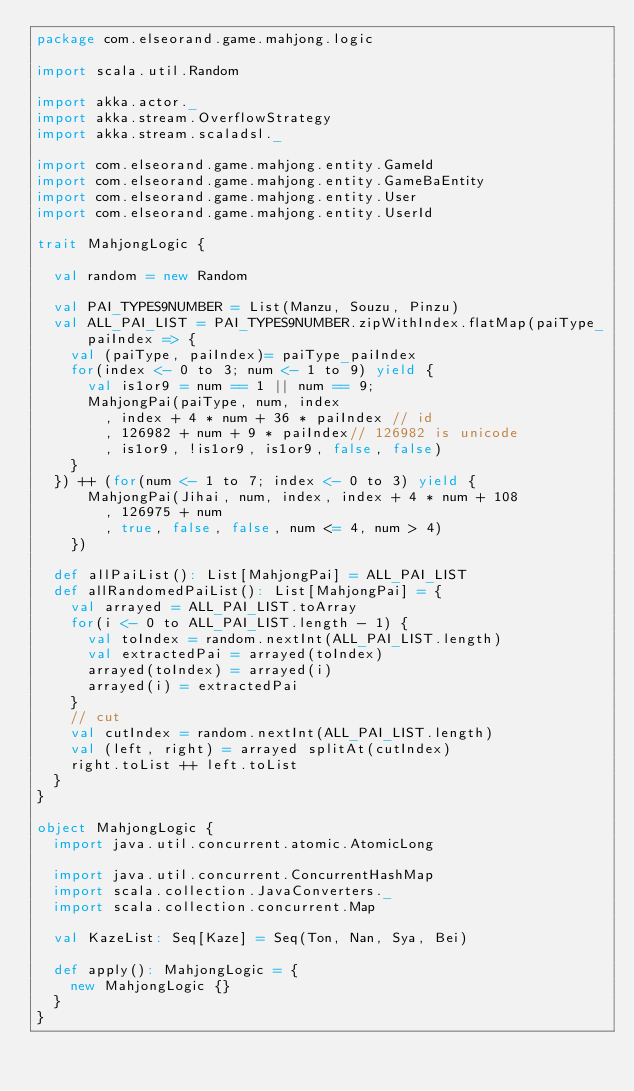<code> <loc_0><loc_0><loc_500><loc_500><_Scala_>package com.elseorand.game.mahjong.logic

import scala.util.Random

import akka.actor._
import akka.stream.OverflowStrategy
import akka.stream.scaladsl._

import com.elseorand.game.mahjong.entity.GameId
import com.elseorand.game.mahjong.entity.GameBaEntity
import com.elseorand.game.mahjong.entity.User
import com.elseorand.game.mahjong.entity.UserId

trait MahjongLogic {

  val random = new Random

  val PAI_TYPES9NUMBER = List(Manzu, Souzu, Pinzu)
  val ALL_PAI_LIST = PAI_TYPES9NUMBER.zipWithIndex.flatMap(paiType_paiIndex => {
    val (paiType, paiIndex)= paiType_paiIndex
    for(index <- 0 to 3; num <- 1 to 9) yield {
      val is1or9 = num == 1 || num == 9;
      MahjongPai(paiType, num, index
        , index + 4 * num + 36 * paiIndex // id
        , 126982 + num + 9 * paiIndex// 126982 is unicode
        , is1or9, !is1or9, is1or9, false, false)
    }
  }) ++ (for(num <- 1 to 7; index <- 0 to 3) yield {
      MahjongPai(Jihai, num, index, index + 4 * num + 108
        , 126975 + num
        , true, false, false, num <= 4, num > 4)
    })

  def allPaiList(): List[MahjongPai] = ALL_PAI_LIST
  def allRandomedPaiList(): List[MahjongPai] = {
    val arrayed = ALL_PAI_LIST.toArray
    for(i <- 0 to ALL_PAI_LIST.length - 1) {
      val toIndex = random.nextInt(ALL_PAI_LIST.length)
      val extractedPai = arrayed(toIndex)
      arrayed(toIndex) = arrayed(i)
      arrayed(i) = extractedPai
    }
    // cut
    val cutIndex = random.nextInt(ALL_PAI_LIST.length)
    val (left, right) = arrayed splitAt(cutIndex)
    right.toList ++ left.toList
  }
}

object MahjongLogic {
  import java.util.concurrent.atomic.AtomicLong

  import java.util.concurrent.ConcurrentHashMap
  import scala.collection.JavaConverters._
  import scala.collection.concurrent.Map

  val KazeList: Seq[Kaze] = Seq(Ton, Nan, Sya, Bei)

  def apply(): MahjongLogic = {
    new MahjongLogic {}
  }
}
</code> 